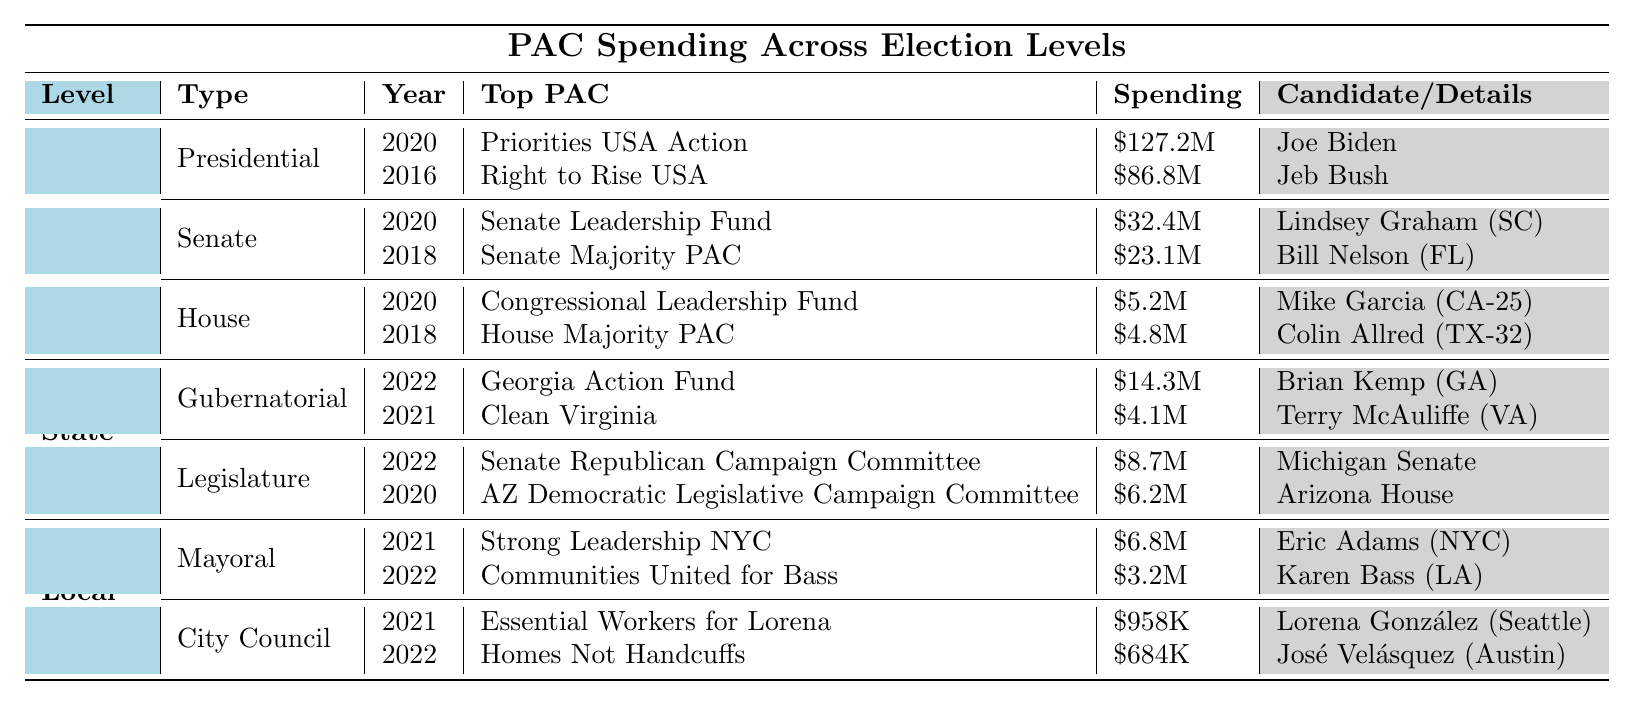What was the top PAC for the presidential election in 2020? The table shows that the top PAC for the presidential election in 2020 is "Priorities USA Action."
Answer: Priorities USA Action How much did the Senate Leadership Fund spend in South Carolina in 2020? The table indicates that the Senate Leadership Fund spent $32.4M in South Carolina in 2020.
Answer: $32.4M Which candidate was supported by the House Majority PAC in 2018? According to the table, the House Majority PAC supported Colin Allred in 2018.
Answer: Colin Allred What is the total spending by the top PACs for Federal House elections listed in the table? The spending for Federal House elections is $5.2M (2020) + $4.8M (2018) = $10M.
Answer: $10M Is there any local election where the spending exceeded $7 million? The table shows that the highest spending in local elections is $6.8M for the mayoral race in New York City in 2021, which does not exceed $7 million.
Answer: No Which election type had the highest spending from a PAC in 2020? In 2020, the highest spending was $127.2M by "Priorities USA Action" in the presidential election, which is the maximum spending amount in the table.
Answer: Presidential election Compare the spending of the top PAC in the gubernatorial race in Georgia to that in the Virginia race in 2021. The Georgia Action Fund spent $14.3M in 2022 while Clean Virginia spent $4.1M in 2021. Thus, $14.3M (GA) > $4.1M (VA).
Answer: Georgia's spending was higher What is the average spending of the top PACs across all local elections listed? The local election spending is $6.8M (NYC) + $3.2M (LA) + $958K (Seattle) + $684K (Austin). Total is $11.7M for 4 entries, giving an average of $11.7M / 4 = $2.925M.
Answer: $2.925M Which chamber of the Michigan state legislature received the highest PAC spending in 2022? The table shows that the Senate in Michigan received $8.7M from the Senate Republican Campaign Committee, which is listed as the spending for that election.
Answer: Senate Did any PAC support a candidate for city council in Austin? Yes, the table records that "Homes Not Handcuffs" supported José Velásquez in Austin during the 2022 city council elections.
Answer: Yes What was the total PAC spending for Federal Senate elections across the years listed? The total spending for Federal Senate elections is $32.4M (2020) + $23.1M (2018) = $55.5M.
Answer: $55.5M 